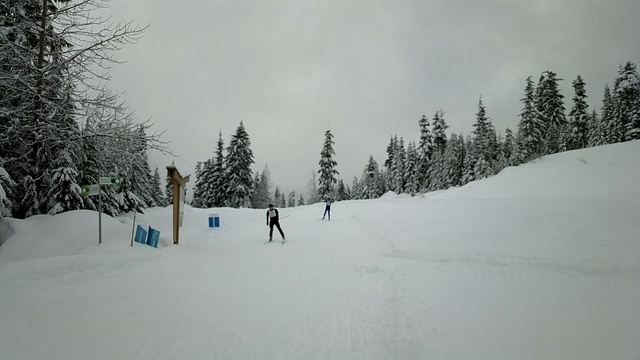Describe the objects in this image and their specific colors. I can see people in black, gray, and darkgray tones, people in black, gray, darkgray, and darkblue tones, skis in darkgray, gray, and black tones, and skis in black and darkgray tones in this image. 